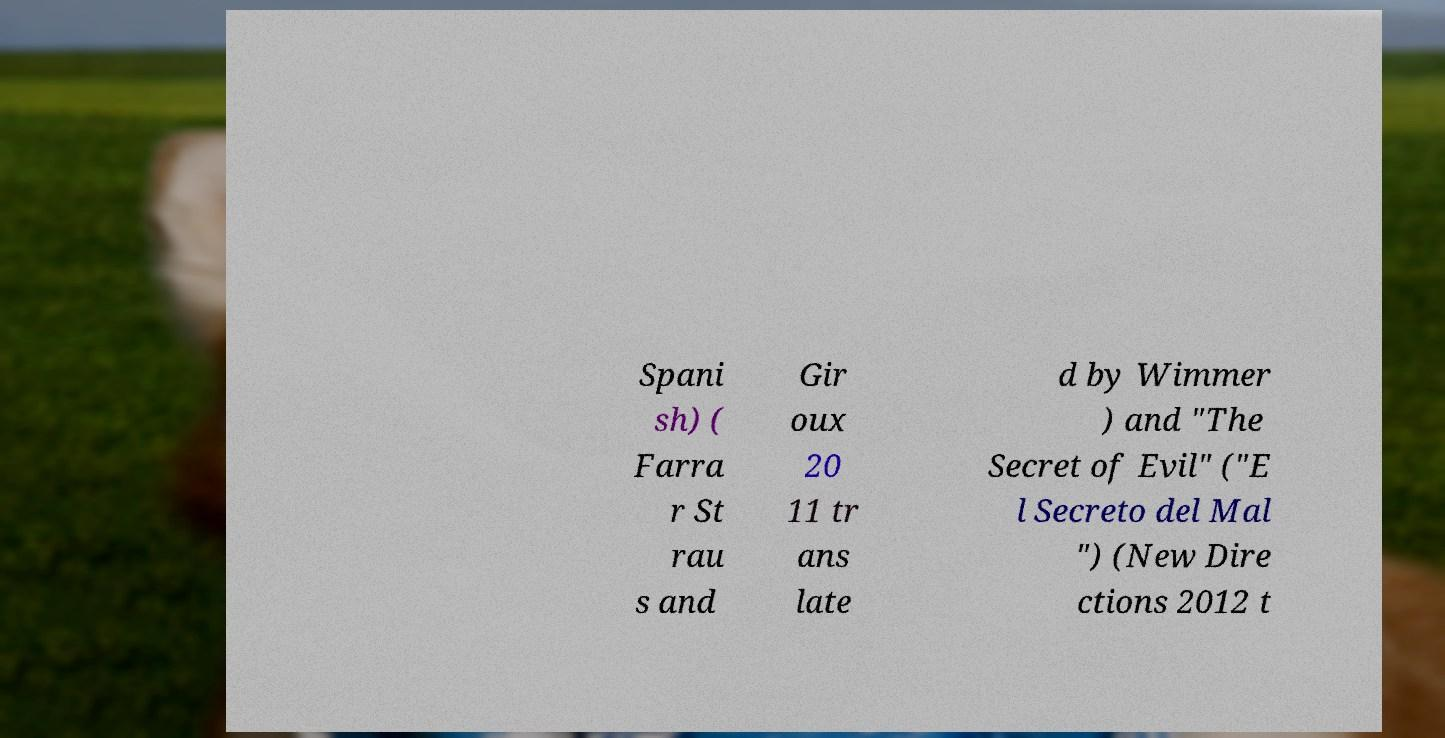Please identify and transcribe the text found in this image. Spani sh) ( Farra r St rau s and Gir oux 20 11 tr ans late d by Wimmer ) and "The Secret of Evil" ("E l Secreto del Mal ") (New Dire ctions 2012 t 